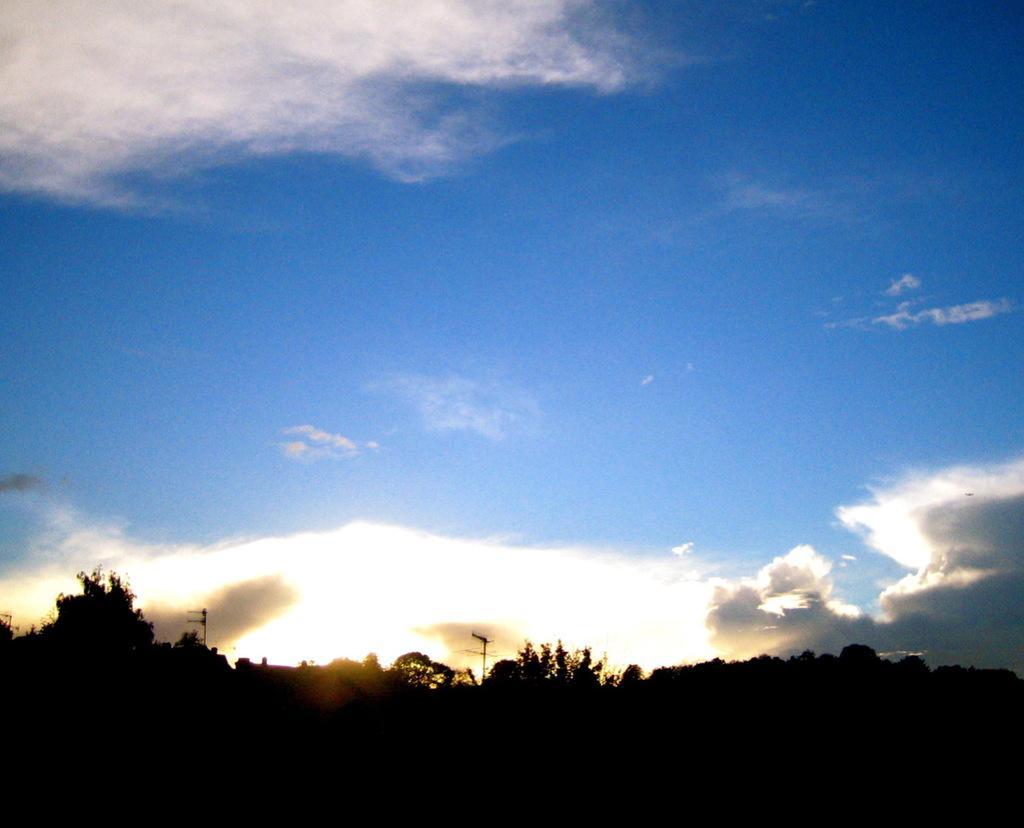Can you describe this image briefly? In this image there are some trees in bottom of this image and there are two current polls in middle of this image and there is a cloudy blue sky at top of this image. 